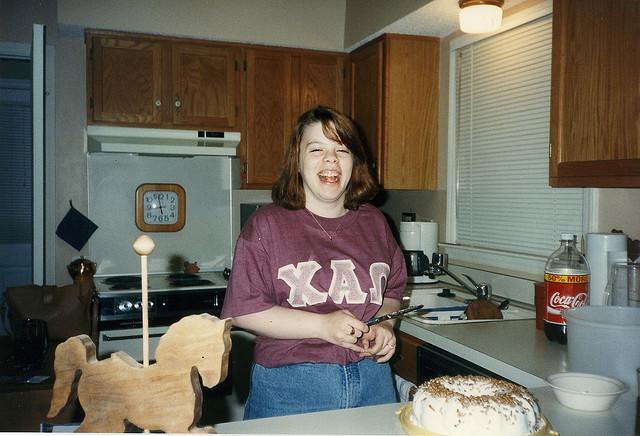Is there a pot on the stove?
Keep it brief. No. What beverage is nearby on the counter?
Give a very brief answer. Coca cola. What does the girl belong to?
Concise answer only. Sorority. Are this person's eyes closed?
Write a very short answer. Yes. What is the child eating?
Give a very brief answer. Cake. 